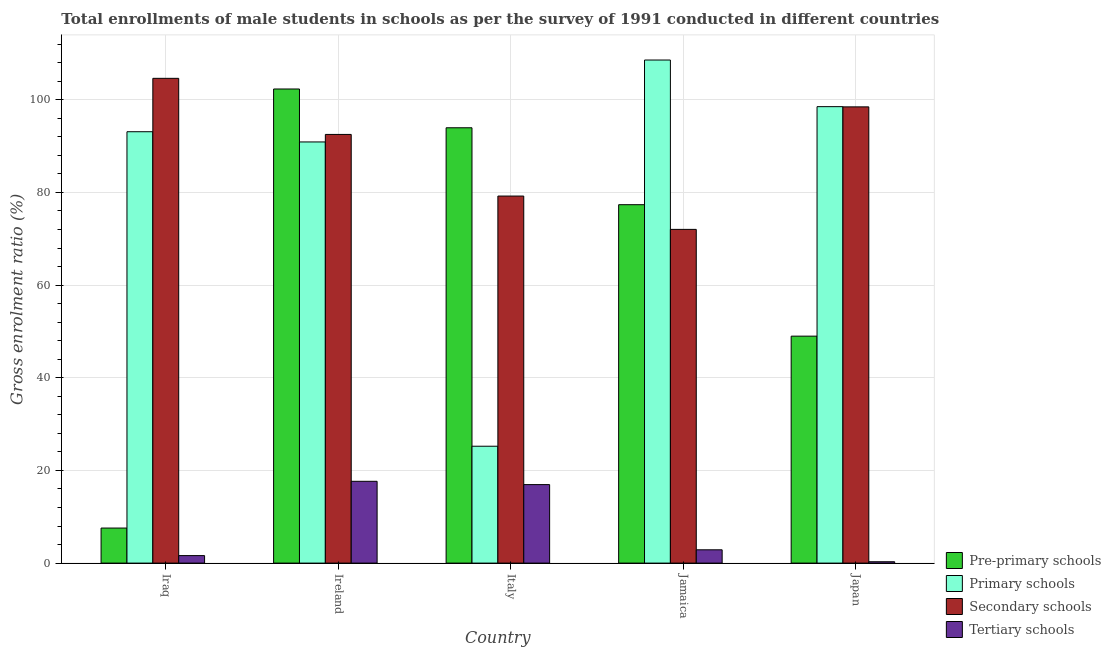How many groups of bars are there?
Ensure brevity in your answer.  5. Are the number of bars per tick equal to the number of legend labels?
Give a very brief answer. Yes. How many bars are there on the 4th tick from the right?
Make the answer very short. 4. What is the label of the 2nd group of bars from the left?
Keep it short and to the point. Ireland. What is the gross enrolment ratio(male) in primary schools in Ireland?
Provide a short and direct response. 90.89. Across all countries, what is the maximum gross enrolment ratio(male) in primary schools?
Offer a very short reply. 108.58. Across all countries, what is the minimum gross enrolment ratio(male) in tertiary schools?
Your answer should be compact. 0.29. In which country was the gross enrolment ratio(male) in tertiary schools maximum?
Your answer should be compact. Ireland. In which country was the gross enrolment ratio(male) in tertiary schools minimum?
Provide a succinct answer. Japan. What is the total gross enrolment ratio(male) in pre-primary schools in the graph?
Provide a succinct answer. 330.17. What is the difference between the gross enrolment ratio(male) in secondary schools in Iraq and that in Ireland?
Offer a terse response. 12.11. What is the difference between the gross enrolment ratio(male) in primary schools in Italy and the gross enrolment ratio(male) in tertiary schools in Japan?
Offer a terse response. 24.93. What is the average gross enrolment ratio(male) in tertiary schools per country?
Ensure brevity in your answer.  7.88. What is the difference between the gross enrolment ratio(male) in pre-primary schools and gross enrolment ratio(male) in primary schools in Ireland?
Provide a short and direct response. 11.43. What is the ratio of the gross enrolment ratio(male) in pre-primary schools in Ireland to that in Italy?
Offer a terse response. 1.09. What is the difference between the highest and the second highest gross enrolment ratio(male) in primary schools?
Make the answer very short. 10.06. What is the difference between the highest and the lowest gross enrolment ratio(male) in tertiary schools?
Keep it short and to the point. 17.36. Is the sum of the gross enrolment ratio(male) in secondary schools in Italy and Japan greater than the maximum gross enrolment ratio(male) in primary schools across all countries?
Ensure brevity in your answer.  Yes. Is it the case that in every country, the sum of the gross enrolment ratio(male) in secondary schools and gross enrolment ratio(male) in pre-primary schools is greater than the sum of gross enrolment ratio(male) in tertiary schools and gross enrolment ratio(male) in primary schools?
Your answer should be very brief. No. What does the 2nd bar from the left in Iraq represents?
Provide a short and direct response. Primary schools. What does the 4th bar from the right in Italy represents?
Offer a terse response. Pre-primary schools. How many bars are there?
Your response must be concise. 20. What is the difference between two consecutive major ticks on the Y-axis?
Offer a very short reply. 20. Are the values on the major ticks of Y-axis written in scientific E-notation?
Provide a short and direct response. No. Does the graph contain grids?
Make the answer very short. Yes. Where does the legend appear in the graph?
Ensure brevity in your answer.  Bottom right. How are the legend labels stacked?
Ensure brevity in your answer.  Vertical. What is the title of the graph?
Make the answer very short. Total enrollments of male students in schools as per the survey of 1991 conducted in different countries. What is the label or title of the X-axis?
Your answer should be compact. Country. What is the label or title of the Y-axis?
Your response must be concise. Gross enrolment ratio (%). What is the Gross enrolment ratio (%) in Pre-primary schools in Iraq?
Keep it short and to the point. 7.56. What is the Gross enrolment ratio (%) in Primary schools in Iraq?
Make the answer very short. 93.1. What is the Gross enrolment ratio (%) in Secondary schools in Iraq?
Offer a terse response. 104.62. What is the Gross enrolment ratio (%) in Tertiary schools in Iraq?
Make the answer very short. 1.62. What is the Gross enrolment ratio (%) in Pre-primary schools in Ireland?
Ensure brevity in your answer.  102.32. What is the Gross enrolment ratio (%) of Primary schools in Ireland?
Keep it short and to the point. 90.89. What is the Gross enrolment ratio (%) in Secondary schools in Ireland?
Make the answer very short. 92.52. What is the Gross enrolment ratio (%) in Tertiary schools in Ireland?
Your response must be concise. 17.65. What is the Gross enrolment ratio (%) of Pre-primary schools in Italy?
Provide a short and direct response. 93.95. What is the Gross enrolment ratio (%) of Primary schools in Italy?
Give a very brief answer. 25.22. What is the Gross enrolment ratio (%) in Secondary schools in Italy?
Give a very brief answer. 79.22. What is the Gross enrolment ratio (%) of Tertiary schools in Italy?
Offer a terse response. 16.94. What is the Gross enrolment ratio (%) in Pre-primary schools in Jamaica?
Offer a terse response. 77.35. What is the Gross enrolment ratio (%) of Primary schools in Jamaica?
Give a very brief answer. 108.58. What is the Gross enrolment ratio (%) of Secondary schools in Jamaica?
Provide a succinct answer. 72.02. What is the Gross enrolment ratio (%) in Tertiary schools in Jamaica?
Your answer should be compact. 2.87. What is the Gross enrolment ratio (%) of Pre-primary schools in Japan?
Your answer should be compact. 48.98. What is the Gross enrolment ratio (%) in Primary schools in Japan?
Ensure brevity in your answer.  98.51. What is the Gross enrolment ratio (%) of Secondary schools in Japan?
Your answer should be compact. 98.47. What is the Gross enrolment ratio (%) of Tertiary schools in Japan?
Provide a succinct answer. 0.29. Across all countries, what is the maximum Gross enrolment ratio (%) in Pre-primary schools?
Make the answer very short. 102.32. Across all countries, what is the maximum Gross enrolment ratio (%) of Primary schools?
Offer a very short reply. 108.58. Across all countries, what is the maximum Gross enrolment ratio (%) of Secondary schools?
Ensure brevity in your answer.  104.62. Across all countries, what is the maximum Gross enrolment ratio (%) of Tertiary schools?
Your answer should be compact. 17.65. Across all countries, what is the minimum Gross enrolment ratio (%) of Pre-primary schools?
Your answer should be compact. 7.56. Across all countries, what is the minimum Gross enrolment ratio (%) of Primary schools?
Ensure brevity in your answer.  25.22. Across all countries, what is the minimum Gross enrolment ratio (%) in Secondary schools?
Offer a terse response. 72.02. Across all countries, what is the minimum Gross enrolment ratio (%) in Tertiary schools?
Provide a short and direct response. 0.29. What is the total Gross enrolment ratio (%) in Pre-primary schools in the graph?
Provide a succinct answer. 330.17. What is the total Gross enrolment ratio (%) of Primary schools in the graph?
Offer a very short reply. 416.31. What is the total Gross enrolment ratio (%) in Secondary schools in the graph?
Keep it short and to the point. 446.85. What is the total Gross enrolment ratio (%) in Tertiary schools in the graph?
Provide a succinct answer. 39.38. What is the difference between the Gross enrolment ratio (%) of Pre-primary schools in Iraq and that in Ireland?
Your answer should be compact. -94.76. What is the difference between the Gross enrolment ratio (%) in Primary schools in Iraq and that in Ireland?
Provide a succinct answer. 2.21. What is the difference between the Gross enrolment ratio (%) in Secondary schools in Iraq and that in Ireland?
Your response must be concise. 12.11. What is the difference between the Gross enrolment ratio (%) in Tertiary schools in Iraq and that in Ireland?
Keep it short and to the point. -16.04. What is the difference between the Gross enrolment ratio (%) in Pre-primary schools in Iraq and that in Italy?
Keep it short and to the point. -86.39. What is the difference between the Gross enrolment ratio (%) of Primary schools in Iraq and that in Italy?
Your response must be concise. 67.88. What is the difference between the Gross enrolment ratio (%) of Secondary schools in Iraq and that in Italy?
Offer a very short reply. 25.4. What is the difference between the Gross enrolment ratio (%) of Tertiary schools in Iraq and that in Italy?
Your answer should be very brief. -15.33. What is the difference between the Gross enrolment ratio (%) of Pre-primary schools in Iraq and that in Jamaica?
Your answer should be compact. -69.79. What is the difference between the Gross enrolment ratio (%) in Primary schools in Iraq and that in Jamaica?
Provide a short and direct response. -15.47. What is the difference between the Gross enrolment ratio (%) of Secondary schools in Iraq and that in Jamaica?
Offer a very short reply. 32.6. What is the difference between the Gross enrolment ratio (%) of Tertiary schools in Iraq and that in Jamaica?
Keep it short and to the point. -1.25. What is the difference between the Gross enrolment ratio (%) in Pre-primary schools in Iraq and that in Japan?
Provide a short and direct response. -41.42. What is the difference between the Gross enrolment ratio (%) in Primary schools in Iraq and that in Japan?
Make the answer very short. -5.41. What is the difference between the Gross enrolment ratio (%) of Secondary schools in Iraq and that in Japan?
Offer a very short reply. 6.16. What is the difference between the Gross enrolment ratio (%) of Tertiary schools in Iraq and that in Japan?
Offer a terse response. 1.32. What is the difference between the Gross enrolment ratio (%) in Pre-primary schools in Ireland and that in Italy?
Make the answer very short. 8.37. What is the difference between the Gross enrolment ratio (%) in Primary schools in Ireland and that in Italy?
Your response must be concise. 65.67. What is the difference between the Gross enrolment ratio (%) in Secondary schools in Ireland and that in Italy?
Provide a succinct answer. 13.3. What is the difference between the Gross enrolment ratio (%) in Tertiary schools in Ireland and that in Italy?
Make the answer very short. 0.71. What is the difference between the Gross enrolment ratio (%) in Pre-primary schools in Ireland and that in Jamaica?
Keep it short and to the point. 24.97. What is the difference between the Gross enrolment ratio (%) of Primary schools in Ireland and that in Jamaica?
Offer a very short reply. -17.68. What is the difference between the Gross enrolment ratio (%) of Secondary schools in Ireland and that in Jamaica?
Your answer should be very brief. 20.5. What is the difference between the Gross enrolment ratio (%) in Tertiary schools in Ireland and that in Jamaica?
Provide a succinct answer. 14.79. What is the difference between the Gross enrolment ratio (%) in Pre-primary schools in Ireland and that in Japan?
Provide a succinct answer. 53.34. What is the difference between the Gross enrolment ratio (%) of Primary schools in Ireland and that in Japan?
Your answer should be compact. -7.62. What is the difference between the Gross enrolment ratio (%) in Secondary schools in Ireland and that in Japan?
Offer a very short reply. -5.95. What is the difference between the Gross enrolment ratio (%) of Tertiary schools in Ireland and that in Japan?
Provide a short and direct response. 17.36. What is the difference between the Gross enrolment ratio (%) of Pre-primary schools in Italy and that in Jamaica?
Make the answer very short. 16.6. What is the difference between the Gross enrolment ratio (%) of Primary schools in Italy and that in Jamaica?
Your answer should be compact. -83.35. What is the difference between the Gross enrolment ratio (%) of Secondary schools in Italy and that in Jamaica?
Ensure brevity in your answer.  7.2. What is the difference between the Gross enrolment ratio (%) of Tertiary schools in Italy and that in Jamaica?
Provide a succinct answer. 14.07. What is the difference between the Gross enrolment ratio (%) of Pre-primary schools in Italy and that in Japan?
Provide a succinct answer. 44.97. What is the difference between the Gross enrolment ratio (%) of Primary schools in Italy and that in Japan?
Make the answer very short. -73.29. What is the difference between the Gross enrolment ratio (%) in Secondary schools in Italy and that in Japan?
Your answer should be very brief. -19.25. What is the difference between the Gross enrolment ratio (%) in Tertiary schools in Italy and that in Japan?
Make the answer very short. 16.65. What is the difference between the Gross enrolment ratio (%) of Pre-primary schools in Jamaica and that in Japan?
Offer a terse response. 28.37. What is the difference between the Gross enrolment ratio (%) in Primary schools in Jamaica and that in Japan?
Provide a succinct answer. 10.06. What is the difference between the Gross enrolment ratio (%) of Secondary schools in Jamaica and that in Japan?
Ensure brevity in your answer.  -26.44. What is the difference between the Gross enrolment ratio (%) of Tertiary schools in Jamaica and that in Japan?
Offer a terse response. 2.58. What is the difference between the Gross enrolment ratio (%) in Pre-primary schools in Iraq and the Gross enrolment ratio (%) in Primary schools in Ireland?
Provide a short and direct response. -83.33. What is the difference between the Gross enrolment ratio (%) of Pre-primary schools in Iraq and the Gross enrolment ratio (%) of Secondary schools in Ireland?
Give a very brief answer. -84.96. What is the difference between the Gross enrolment ratio (%) of Pre-primary schools in Iraq and the Gross enrolment ratio (%) of Tertiary schools in Ireland?
Your answer should be very brief. -10.09. What is the difference between the Gross enrolment ratio (%) of Primary schools in Iraq and the Gross enrolment ratio (%) of Secondary schools in Ireland?
Provide a short and direct response. 0.58. What is the difference between the Gross enrolment ratio (%) of Primary schools in Iraq and the Gross enrolment ratio (%) of Tertiary schools in Ireland?
Your answer should be compact. 75.45. What is the difference between the Gross enrolment ratio (%) of Secondary schools in Iraq and the Gross enrolment ratio (%) of Tertiary schools in Ireland?
Provide a succinct answer. 86.97. What is the difference between the Gross enrolment ratio (%) in Pre-primary schools in Iraq and the Gross enrolment ratio (%) in Primary schools in Italy?
Provide a short and direct response. -17.66. What is the difference between the Gross enrolment ratio (%) in Pre-primary schools in Iraq and the Gross enrolment ratio (%) in Secondary schools in Italy?
Provide a short and direct response. -71.66. What is the difference between the Gross enrolment ratio (%) in Pre-primary schools in Iraq and the Gross enrolment ratio (%) in Tertiary schools in Italy?
Provide a short and direct response. -9.38. What is the difference between the Gross enrolment ratio (%) in Primary schools in Iraq and the Gross enrolment ratio (%) in Secondary schools in Italy?
Offer a terse response. 13.88. What is the difference between the Gross enrolment ratio (%) of Primary schools in Iraq and the Gross enrolment ratio (%) of Tertiary schools in Italy?
Make the answer very short. 76.16. What is the difference between the Gross enrolment ratio (%) in Secondary schools in Iraq and the Gross enrolment ratio (%) in Tertiary schools in Italy?
Keep it short and to the point. 87.68. What is the difference between the Gross enrolment ratio (%) of Pre-primary schools in Iraq and the Gross enrolment ratio (%) of Primary schools in Jamaica?
Your answer should be very brief. -101.01. What is the difference between the Gross enrolment ratio (%) of Pre-primary schools in Iraq and the Gross enrolment ratio (%) of Secondary schools in Jamaica?
Offer a terse response. -64.46. What is the difference between the Gross enrolment ratio (%) of Pre-primary schools in Iraq and the Gross enrolment ratio (%) of Tertiary schools in Jamaica?
Ensure brevity in your answer.  4.69. What is the difference between the Gross enrolment ratio (%) of Primary schools in Iraq and the Gross enrolment ratio (%) of Secondary schools in Jamaica?
Ensure brevity in your answer.  21.08. What is the difference between the Gross enrolment ratio (%) of Primary schools in Iraq and the Gross enrolment ratio (%) of Tertiary schools in Jamaica?
Your answer should be compact. 90.23. What is the difference between the Gross enrolment ratio (%) in Secondary schools in Iraq and the Gross enrolment ratio (%) in Tertiary schools in Jamaica?
Offer a terse response. 101.75. What is the difference between the Gross enrolment ratio (%) in Pre-primary schools in Iraq and the Gross enrolment ratio (%) in Primary schools in Japan?
Ensure brevity in your answer.  -90.95. What is the difference between the Gross enrolment ratio (%) of Pre-primary schools in Iraq and the Gross enrolment ratio (%) of Secondary schools in Japan?
Your response must be concise. -90.9. What is the difference between the Gross enrolment ratio (%) of Pre-primary schools in Iraq and the Gross enrolment ratio (%) of Tertiary schools in Japan?
Offer a terse response. 7.27. What is the difference between the Gross enrolment ratio (%) of Primary schools in Iraq and the Gross enrolment ratio (%) of Secondary schools in Japan?
Offer a terse response. -5.37. What is the difference between the Gross enrolment ratio (%) of Primary schools in Iraq and the Gross enrolment ratio (%) of Tertiary schools in Japan?
Keep it short and to the point. 92.81. What is the difference between the Gross enrolment ratio (%) in Secondary schools in Iraq and the Gross enrolment ratio (%) in Tertiary schools in Japan?
Offer a very short reply. 104.33. What is the difference between the Gross enrolment ratio (%) in Pre-primary schools in Ireland and the Gross enrolment ratio (%) in Primary schools in Italy?
Ensure brevity in your answer.  77.1. What is the difference between the Gross enrolment ratio (%) of Pre-primary schools in Ireland and the Gross enrolment ratio (%) of Secondary schools in Italy?
Make the answer very short. 23.11. What is the difference between the Gross enrolment ratio (%) in Pre-primary schools in Ireland and the Gross enrolment ratio (%) in Tertiary schools in Italy?
Make the answer very short. 85.38. What is the difference between the Gross enrolment ratio (%) of Primary schools in Ireland and the Gross enrolment ratio (%) of Secondary schools in Italy?
Make the answer very short. 11.68. What is the difference between the Gross enrolment ratio (%) of Primary schools in Ireland and the Gross enrolment ratio (%) of Tertiary schools in Italy?
Provide a short and direct response. 73.95. What is the difference between the Gross enrolment ratio (%) in Secondary schools in Ireland and the Gross enrolment ratio (%) in Tertiary schools in Italy?
Your answer should be very brief. 75.58. What is the difference between the Gross enrolment ratio (%) of Pre-primary schools in Ireland and the Gross enrolment ratio (%) of Primary schools in Jamaica?
Offer a very short reply. -6.25. What is the difference between the Gross enrolment ratio (%) in Pre-primary schools in Ireland and the Gross enrolment ratio (%) in Secondary schools in Jamaica?
Provide a short and direct response. 30.3. What is the difference between the Gross enrolment ratio (%) in Pre-primary schools in Ireland and the Gross enrolment ratio (%) in Tertiary schools in Jamaica?
Your answer should be compact. 99.45. What is the difference between the Gross enrolment ratio (%) in Primary schools in Ireland and the Gross enrolment ratio (%) in Secondary schools in Jamaica?
Your response must be concise. 18.87. What is the difference between the Gross enrolment ratio (%) of Primary schools in Ireland and the Gross enrolment ratio (%) of Tertiary schools in Jamaica?
Offer a very short reply. 88.03. What is the difference between the Gross enrolment ratio (%) in Secondary schools in Ireland and the Gross enrolment ratio (%) in Tertiary schools in Jamaica?
Make the answer very short. 89.65. What is the difference between the Gross enrolment ratio (%) of Pre-primary schools in Ireland and the Gross enrolment ratio (%) of Primary schools in Japan?
Give a very brief answer. 3.81. What is the difference between the Gross enrolment ratio (%) of Pre-primary schools in Ireland and the Gross enrolment ratio (%) of Secondary schools in Japan?
Your answer should be very brief. 3.86. What is the difference between the Gross enrolment ratio (%) of Pre-primary schools in Ireland and the Gross enrolment ratio (%) of Tertiary schools in Japan?
Offer a very short reply. 102.03. What is the difference between the Gross enrolment ratio (%) in Primary schools in Ireland and the Gross enrolment ratio (%) in Secondary schools in Japan?
Keep it short and to the point. -7.57. What is the difference between the Gross enrolment ratio (%) of Primary schools in Ireland and the Gross enrolment ratio (%) of Tertiary schools in Japan?
Keep it short and to the point. 90.6. What is the difference between the Gross enrolment ratio (%) of Secondary schools in Ireland and the Gross enrolment ratio (%) of Tertiary schools in Japan?
Provide a succinct answer. 92.22. What is the difference between the Gross enrolment ratio (%) in Pre-primary schools in Italy and the Gross enrolment ratio (%) in Primary schools in Jamaica?
Make the answer very short. -14.62. What is the difference between the Gross enrolment ratio (%) of Pre-primary schools in Italy and the Gross enrolment ratio (%) of Secondary schools in Jamaica?
Your response must be concise. 21.93. What is the difference between the Gross enrolment ratio (%) in Pre-primary schools in Italy and the Gross enrolment ratio (%) in Tertiary schools in Jamaica?
Your answer should be compact. 91.09. What is the difference between the Gross enrolment ratio (%) of Primary schools in Italy and the Gross enrolment ratio (%) of Secondary schools in Jamaica?
Keep it short and to the point. -46.8. What is the difference between the Gross enrolment ratio (%) of Primary schools in Italy and the Gross enrolment ratio (%) of Tertiary schools in Jamaica?
Your response must be concise. 22.36. What is the difference between the Gross enrolment ratio (%) in Secondary schools in Italy and the Gross enrolment ratio (%) in Tertiary schools in Jamaica?
Make the answer very short. 76.35. What is the difference between the Gross enrolment ratio (%) in Pre-primary schools in Italy and the Gross enrolment ratio (%) in Primary schools in Japan?
Give a very brief answer. -4.56. What is the difference between the Gross enrolment ratio (%) in Pre-primary schools in Italy and the Gross enrolment ratio (%) in Secondary schools in Japan?
Keep it short and to the point. -4.51. What is the difference between the Gross enrolment ratio (%) in Pre-primary schools in Italy and the Gross enrolment ratio (%) in Tertiary schools in Japan?
Offer a very short reply. 93.66. What is the difference between the Gross enrolment ratio (%) in Primary schools in Italy and the Gross enrolment ratio (%) in Secondary schools in Japan?
Keep it short and to the point. -73.24. What is the difference between the Gross enrolment ratio (%) of Primary schools in Italy and the Gross enrolment ratio (%) of Tertiary schools in Japan?
Provide a succinct answer. 24.93. What is the difference between the Gross enrolment ratio (%) in Secondary schools in Italy and the Gross enrolment ratio (%) in Tertiary schools in Japan?
Provide a short and direct response. 78.92. What is the difference between the Gross enrolment ratio (%) in Pre-primary schools in Jamaica and the Gross enrolment ratio (%) in Primary schools in Japan?
Keep it short and to the point. -21.16. What is the difference between the Gross enrolment ratio (%) of Pre-primary schools in Jamaica and the Gross enrolment ratio (%) of Secondary schools in Japan?
Provide a short and direct response. -21.11. What is the difference between the Gross enrolment ratio (%) in Pre-primary schools in Jamaica and the Gross enrolment ratio (%) in Tertiary schools in Japan?
Your answer should be compact. 77.06. What is the difference between the Gross enrolment ratio (%) of Primary schools in Jamaica and the Gross enrolment ratio (%) of Secondary schools in Japan?
Your response must be concise. 10.11. What is the difference between the Gross enrolment ratio (%) in Primary schools in Jamaica and the Gross enrolment ratio (%) in Tertiary schools in Japan?
Your answer should be very brief. 108.28. What is the difference between the Gross enrolment ratio (%) of Secondary schools in Jamaica and the Gross enrolment ratio (%) of Tertiary schools in Japan?
Ensure brevity in your answer.  71.73. What is the average Gross enrolment ratio (%) in Pre-primary schools per country?
Keep it short and to the point. 66.03. What is the average Gross enrolment ratio (%) in Primary schools per country?
Provide a succinct answer. 83.26. What is the average Gross enrolment ratio (%) in Secondary schools per country?
Provide a succinct answer. 89.37. What is the average Gross enrolment ratio (%) of Tertiary schools per country?
Give a very brief answer. 7.88. What is the difference between the Gross enrolment ratio (%) in Pre-primary schools and Gross enrolment ratio (%) in Primary schools in Iraq?
Keep it short and to the point. -85.54. What is the difference between the Gross enrolment ratio (%) of Pre-primary schools and Gross enrolment ratio (%) of Secondary schools in Iraq?
Make the answer very short. -97.06. What is the difference between the Gross enrolment ratio (%) of Pre-primary schools and Gross enrolment ratio (%) of Tertiary schools in Iraq?
Your response must be concise. 5.95. What is the difference between the Gross enrolment ratio (%) of Primary schools and Gross enrolment ratio (%) of Secondary schools in Iraq?
Your response must be concise. -11.52. What is the difference between the Gross enrolment ratio (%) of Primary schools and Gross enrolment ratio (%) of Tertiary schools in Iraq?
Make the answer very short. 91.48. What is the difference between the Gross enrolment ratio (%) of Secondary schools and Gross enrolment ratio (%) of Tertiary schools in Iraq?
Make the answer very short. 103.01. What is the difference between the Gross enrolment ratio (%) of Pre-primary schools and Gross enrolment ratio (%) of Primary schools in Ireland?
Keep it short and to the point. 11.43. What is the difference between the Gross enrolment ratio (%) of Pre-primary schools and Gross enrolment ratio (%) of Secondary schools in Ireland?
Provide a short and direct response. 9.81. What is the difference between the Gross enrolment ratio (%) of Pre-primary schools and Gross enrolment ratio (%) of Tertiary schools in Ireland?
Ensure brevity in your answer.  84.67. What is the difference between the Gross enrolment ratio (%) in Primary schools and Gross enrolment ratio (%) in Secondary schools in Ireland?
Give a very brief answer. -1.62. What is the difference between the Gross enrolment ratio (%) in Primary schools and Gross enrolment ratio (%) in Tertiary schools in Ireland?
Make the answer very short. 73.24. What is the difference between the Gross enrolment ratio (%) of Secondary schools and Gross enrolment ratio (%) of Tertiary schools in Ireland?
Offer a very short reply. 74.86. What is the difference between the Gross enrolment ratio (%) of Pre-primary schools and Gross enrolment ratio (%) of Primary schools in Italy?
Provide a succinct answer. 68.73. What is the difference between the Gross enrolment ratio (%) of Pre-primary schools and Gross enrolment ratio (%) of Secondary schools in Italy?
Ensure brevity in your answer.  14.74. What is the difference between the Gross enrolment ratio (%) of Pre-primary schools and Gross enrolment ratio (%) of Tertiary schools in Italy?
Your response must be concise. 77.01. What is the difference between the Gross enrolment ratio (%) of Primary schools and Gross enrolment ratio (%) of Secondary schools in Italy?
Your answer should be compact. -53.99. What is the difference between the Gross enrolment ratio (%) of Primary schools and Gross enrolment ratio (%) of Tertiary schools in Italy?
Provide a short and direct response. 8.28. What is the difference between the Gross enrolment ratio (%) in Secondary schools and Gross enrolment ratio (%) in Tertiary schools in Italy?
Your answer should be compact. 62.28. What is the difference between the Gross enrolment ratio (%) in Pre-primary schools and Gross enrolment ratio (%) in Primary schools in Jamaica?
Your answer should be compact. -31.22. What is the difference between the Gross enrolment ratio (%) in Pre-primary schools and Gross enrolment ratio (%) in Secondary schools in Jamaica?
Provide a short and direct response. 5.33. What is the difference between the Gross enrolment ratio (%) in Pre-primary schools and Gross enrolment ratio (%) in Tertiary schools in Jamaica?
Provide a succinct answer. 74.48. What is the difference between the Gross enrolment ratio (%) in Primary schools and Gross enrolment ratio (%) in Secondary schools in Jamaica?
Provide a short and direct response. 36.55. What is the difference between the Gross enrolment ratio (%) in Primary schools and Gross enrolment ratio (%) in Tertiary schools in Jamaica?
Your answer should be very brief. 105.71. What is the difference between the Gross enrolment ratio (%) of Secondary schools and Gross enrolment ratio (%) of Tertiary schools in Jamaica?
Make the answer very short. 69.15. What is the difference between the Gross enrolment ratio (%) of Pre-primary schools and Gross enrolment ratio (%) of Primary schools in Japan?
Provide a succinct answer. -49.53. What is the difference between the Gross enrolment ratio (%) of Pre-primary schools and Gross enrolment ratio (%) of Secondary schools in Japan?
Offer a terse response. -49.49. What is the difference between the Gross enrolment ratio (%) in Pre-primary schools and Gross enrolment ratio (%) in Tertiary schools in Japan?
Provide a short and direct response. 48.69. What is the difference between the Gross enrolment ratio (%) of Primary schools and Gross enrolment ratio (%) of Secondary schools in Japan?
Keep it short and to the point. 0.05. What is the difference between the Gross enrolment ratio (%) in Primary schools and Gross enrolment ratio (%) in Tertiary schools in Japan?
Your answer should be very brief. 98.22. What is the difference between the Gross enrolment ratio (%) in Secondary schools and Gross enrolment ratio (%) in Tertiary schools in Japan?
Your answer should be compact. 98.17. What is the ratio of the Gross enrolment ratio (%) in Pre-primary schools in Iraq to that in Ireland?
Offer a terse response. 0.07. What is the ratio of the Gross enrolment ratio (%) of Primary schools in Iraq to that in Ireland?
Offer a very short reply. 1.02. What is the ratio of the Gross enrolment ratio (%) in Secondary schools in Iraq to that in Ireland?
Your response must be concise. 1.13. What is the ratio of the Gross enrolment ratio (%) of Tertiary schools in Iraq to that in Ireland?
Ensure brevity in your answer.  0.09. What is the ratio of the Gross enrolment ratio (%) in Pre-primary schools in Iraq to that in Italy?
Your response must be concise. 0.08. What is the ratio of the Gross enrolment ratio (%) of Primary schools in Iraq to that in Italy?
Make the answer very short. 3.69. What is the ratio of the Gross enrolment ratio (%) of Secondary schools in Iraq to that in Italy?
Offer a terse response. 1.32. What is the ratio of the Gross enrolment ratio (%) of Tertiary schools in Iraq to that in Italy?
Provide a succinct answer. 0.1. What is the ratio of the Gross enrolment ratio (%) in Pre-primary schools in Iraq to that in Jamaica?
Make the answer very short. 0.1. What is the ratio of the Gross enrolment ratio (%) in Primary schools in Iraq to that in Jamaica?
Offer a very short reply. 0.86. What is the ratio of the Gross enrolment ratio (%) in Secondary schools in Iraq to that in Jamaica?
Make the answer very short. 1.45. What is the ratio of the Gross enrolment ratio (%) in Tertiary schools in Iraq to that in Jamaica?
Offer a very short reply. 0.56. What is the ratio of the Gross enrolment ratio (%) in Pre-primary schools in Iraq to that in Japan?
Offer a terse response. 0.15. What is the ratio of the Gross enrolment ratio (%) in Primary schools in Iraq to that in Japan?
Keep it short and to the point. 0.95. What is the ratio of the Gross enrolment ratio (%) of Tertiary schools in Iraq to that in Japan?
Ensure brevity in your answer.  5.5. What is the ratio of the Gross enrolment ratio (%) of Pre-primary schools in Ireland to that in Italy?
Provide a short and direct response. 1.09. What is the ratio of the Gross enrolment ratio (%) in Primary schools in Ireland to that in Italy?
Keep it short and to the point. 3.6. What is the ratio of the Gross enrolment ratio (%) of Secondary schools in Ireland to that in Italy?
Your response must be concise. 1.17. What is the ratio of the Gross enrolment ratio (%) in Tertiary schools in Ireland to that in Italy?
Give a very brief answer. 1.04. What is the ratio of the Gross enrolment ratio (%) in Pre-primary schools in Ireland to that in Jamaica?
Your answer should be very brief. 1.32. What is the ratio of the Gross enrolment ratio (%) of Primary schools in Ireland to that in Jamaica?
Your response must be concise. 0.84. What is the ratio of the Gross enrolment ratio (%) of Secondary schools in Ireland to that in Jamaica?
Your answer should be very brief. 1.28. What is the ratio of the Gross enrolment ratio (%) in Tertiary schools in Ireland to that in Jamaica?
Offer a terse response. 6.15. What is the ratio of the Gross enrolment ratio (%) in Pre-primary schools in Ireland to that in Japan?
Provide a succinct answer. 2.09. What is the ratio of the Gross enrolment ratio (%) of Primary schools in Ireland to that in Japan?
Give a very brief answer. 0.92. What is the ratio of the Gross enrolment ratio (%) in Secondary schools in Ireland to that in Japan?
Make the answer very short. 0.94. What is the ratio of the Gross enrolment ratio (%) in Tertiary schools in Ireland to that in Japan?
Your answer should be compact. 60.1. What is the ratio of the Gross enrolment ratio (%) in Pre-primary schools in Italy to that in Jamaica?
Offer a terse response. 1.21. What is the ratio of the Gross enrolment ratio (%) of Primary schools in Italy to that in Jamaica?
Give a very brief answer. 0.23. What is the ratio of the Gross enrolment ratio (%) in Secondary schools in Italy to that in Jamaica?
Your response must be concise. 1.1. What is the ratio of the Gross enrolment ratio (%) in Tertiary schools in Italy to that in Jamaica?
Your response must be concise. 5.91. What is the ratio of the Gross enrolment ratio (%) in Pre-primary schools in Italy to that in Japan?
Give a very brief answer. 1.92. What is the ratio of the Gross enrolment ratio (%) in Primary schools in Italy to that in Japan?
Ensure brevity in your answer.  0.26. What is the ratio of the Gross enrolment ratio (%) of Secondary schools in Italy to that in Japan?
Your answer should be compact. 0.8. What is the ratio of the Gross enrolment ratio (%) in Tertiary schools in Italy to that in Japan?
Ensure brevity in your answer.  57.68. What is the ratio of the Gross enrolment ratio (%) in Pre-primary schools in Jamaica to that in Japan?
Ensure brevity in your answer.  1.58. What is the ratio of the Gross enrolment ratio (%) in Primary schools in Jamaica to that in Japan?
Make the answer very short. 1.1. What is the ratio of the Gross enrolment ratio (%) of Secondary schools in Jamaica to that in Japan?
Give a very brief answer. 0.73. What is the ratio of the Gross enrolment ratio (%) in Tertiary schools in Jamaica to that in Japan?
Keep it short and to the point. 9.77. What is the difference between the highest and the second highest Gross enrolment ratio (%) of Pre-primary schools?
Make the answer very short. 8.37. What is the difference between the highest and the second highest Gross enrolment ratio (%) in Primary schools?
Give a very brief answer. 10.06. What is the difference between the highest and the second highest Gross enrolment ratio (%) in Secondary schools?
Your answer should be very brief. 6.16. What is the difference between the highest and the second highest Gross enrolment ratio (%) in Tertiary schools?
Your response must be concise. 0.71. What is the difference between the highest and the lowest Gross enrolment ratio (%) of Pre-primary schools?
Make the answer very short. 94.76. What is the difference between the highest and the lowest Gross enrolment ratio (%) in Primary schools?
Your answer should be compact. 83.35. What is the difference between the highest and the lowest Gross enrolment ratio (%) in Secondary schools?
Ensure brevity in your answer.  32.6. What is the difference between the highest and the lowest Gross enrolment ratio (%) in Tertiary schools?
Offer a very short reply. 17.36. 